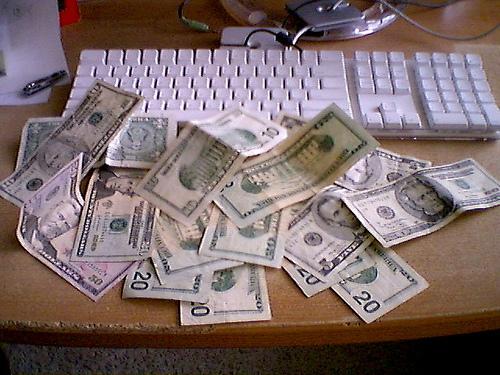Is that American money?
Give a very brief answer. Yes. Why was the picture taken?
Write a very short answer. Show off money. How many 5 dollar bills are visible?
Quick response, please. 1. What is on the desk behind the money?
Be succinct. Keyboard. 